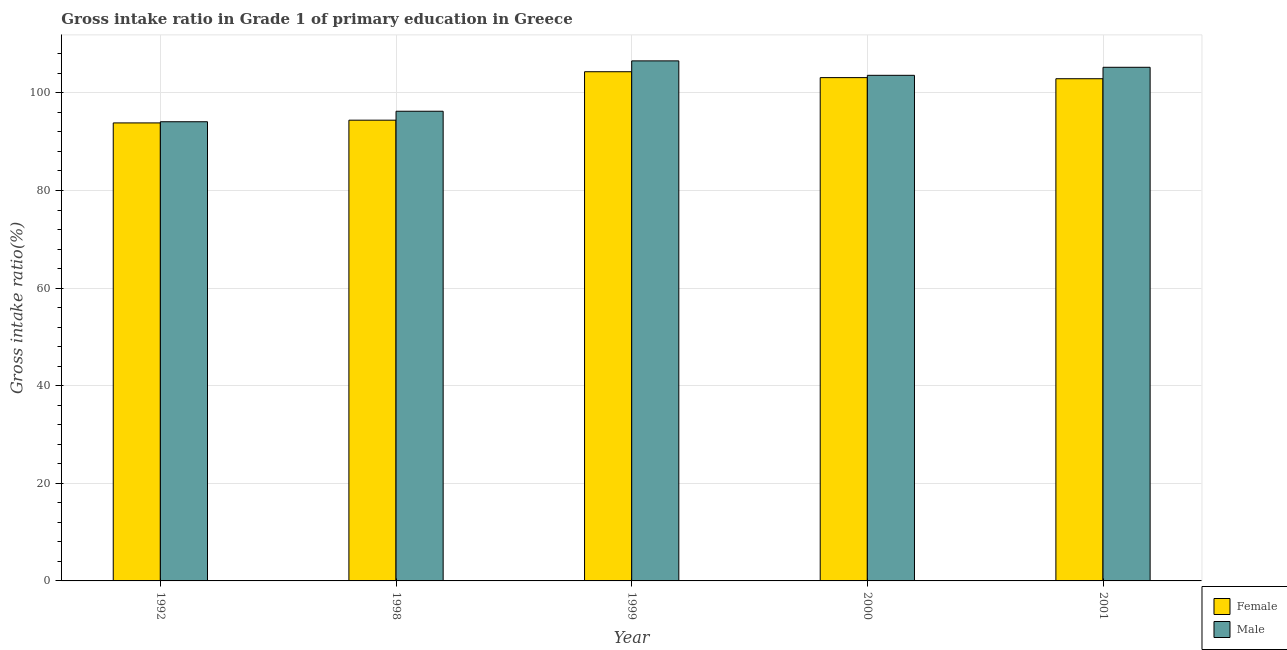How many groups of bars are there?
Provide a short and direct response. 5. Are the number of bars per tick equal to the number of legend labels?
Your response must be concise. Yes. Are the number of bars on each tick of the X-axis equal?
Offer a very short reply. Yes. How many bars are there on the 1st tick from the left?
Provide a succinct answer. 2. How many bars are there on the 1st tick from the right?
Offer a terse response. 2. What is the label of the 2nd group of bars from the left?
Offer a terse response. 1998. What is the gross intake ratio(female) in 1992?
Provide a short and direct response. 93.85. Across all years, what is the maximum gross intake ratio(female)?
Your answer should be very brief. 104.33. Across all years, what is the minimum gross intake ratio(male)?
Your answer should be compact. 94.09. In which year was the gross intake ratio(female) minimum?
Ensure brevity in your answer.  1992. What is the total gross intake ratio(female) in the graph?
Give a very brief answer. 498.61. What is the difference between the gross intake ratio(male) in 1992 and that in 2000?
Offer a very short reply. -9.51. What is the difference between the gross intake ratio(female) in 2001 and the gross intake ratio(male) in 1998?
Offer a terse response. 8.49. What is the average gross intake ratio(female) per year?
Make the answer very short. 99.72. In the year 2000, what is the difference between the gross intake ratio(female) and gross intake ratio(male)?
Your response must be concise. 0. In how many years, is the gross intake ratio(male) greater than 16 %?
Keep it short and to the point. 5. What is the ratio of the gross intake ratio(male) in 1992 to that in 2000?
Offer a terse response. 0.91. Is the gross intake ratio(female) in 1992 less than that in 2001?
Offer a terse response. Yes. Is the difference between the gross intake ratio(male) in 1992 and 2000 greater than the difference between the gross intake ratio(female) in 1992 and 2000?
Provide a succinct answer. No. What is the difference between the highest and the second highest gross intake ratio(male)?
Your answer should be very brief. 1.31. What is the difference between the highest and the lowest gross intake ratio(male)?
Provide a short and direct response. 12.47. In how many years, is the gross intake ratio(female) greater than the average gross intake ratio(female) taken over all years?
Provide a succinct answer. 3. Are all the bars in the graph horizontal?
Provide a succinct answer. No. How many years are there in the graph?
Offer a terse response. 5. Are the values on the major ticks of Y-axis written in scientific E-notation?
Offer a terse response. No. Does the graph contain any zero values?
Offer a very short reply. No. Does the graph contain grids?
Provide a succinct answer. Yes. Where does the legend appear in the graph?
Provide a succinct answer. Bottom right. How many legend labels are there?
Your response must be concise. 2. How are the legend labels stacked?
Give a very brief answer. Vertical. What is the title of the graph?
Provide a succinct answer. Gross intake ratio in Grade 1 of primary education in Greece. Does "Private consumption" appear as one of the legend labels in the graph?
Offer a very short reply. No. What is the label or title of the X-axis?
Ensure brevity in your answer.  Year. What is the label or title of the Y-axis?
Offer a very short reply. Gross intake ratio(%). What is the Gross intake ratio(%) in Female in 1992?
Your answer should be compact. 93.85. What is the Gross intake ratio(%) in Male in 1992?
Provide a short and direct response. 94.09. What is the Gross intake ratio(%) in Female in 1998?
Provide a short and direct response. 94.41. What is the Gross intake ratio(%) in Male in 1998?
Your answer should be compact. 96.24. What is the Gross intake ratio(%) of Female in 1999?
Offer a terse response. 104.33. What is the Gross intake ratio(%) in Male in 1999?
Offer a very short reply. 106.56. What is the Gross intake ratio(%) of Female in 2000?
Offer a very short reply. 103.13. What is the Gross intake ratio(%) in Male in 2000?
Offer a terse response. 103.6. What is the Gross intake ratio(%) of Female in 2001?
Your response must be concise. 102.9. What is the Gross intake ratio(%) of Male in 2001?
Provide a succinct answer. 105.25. Across all years, what is the maximum Gross intake ratio(%) in Female?
Your answer should be very brief. 104.33. Across all years, what is the maximum Gross intake ratio(%) in Male?
Offer a very short reply. 106.56. Across all years, what is the minimum Gross intake ratio(%) of Female?
Make the answer very short. 93.85. Across all years, what is the minimum Gross intake ratio(%) of Male?
Provide a short and direct response. 94.09. What is the total Gross intake ratio(%) of Female in the graph?
Give a very brief answer. 498.61. What is the total Gross intake ratio(%) in Male in the graph?
Your response must be concise. 505.72. What is the difference between the Gross intake ratio(%) of Female in 1992 and that in 1998?
Provide a succinct answer. -0.56. What is the difference between the Gross intake ratio(%) in Male in 1992 and that in 1998?
Give a very brief answer. -2.15. What is the difference between the Gross intake ratio(%) of Female in 1992 and that in 1999?
Ensure brevity in your answer.  -10.49. What is the difference between the Gross intake ratio(%) of Male in 1992 and that in 1999?
Provide a succinct answer. -12.47. What is the difference between the Gross intake ratio(%) in Female in 1992 and that in 2000?
Provide a short and direct response. -9.28. What is the difference between the Gross intake ratio(%) of Male in 1992 and that in 2000?
Provide a succinct answer. -9.51. What is the difference between the Gross intake ratio(%) in Female in 1992 and that in 2001?
Provide a short and direct response. -9.05. What is the difference between the Gross intake ratio(%) in Male in 1992 and that in 2001?
Your answer should be very brief. -11.16. What is the difference between the Gross intake ratio(%) of Female in 1998 and that in 1999?
Keep it short and to the point. -9.93. What is the difference between the Gross intake ratio(%) in Male in 1998 and that in 1999?
Your answer should be very brief. -10.32. What is the difference between the Gross intake ratio(%) of Female in 1998 and that in 2000?
Make the answer very short. -8.72. What is the difference between the Gross intake ratio(%) of Male in 1998 and that in 2000?
Offer a terse response. -7.36. What is the difference between the Gross intake ratio(%) of Female in 1998 and that in 2001?
Keep it short and to the point. -8.49. What is the difference between the Gross intake ratio(%) in Male in 1998 and that in 2001?
Ensure brevity in your answer.  -9.01. What is the difference between the Gross intake ratio(%) of Female in 1999 and that in 2000?
Keep it short and to the point. 1.21. What is the difference between the Gross intake ratio(%) of Male in 1999 and that in 2000?
Make the answer very short. 2.96. What is the difference between the Gross intake ratio(%) of Female in 1999 and that in 2001?
Provide a succinct answer. 1.44. What is the difference between the Gross intake ratio(%) of Male in 1999 and that in 2001?
Ensure brevity in your answer.  1.31. What is the difference between the Gross intake ratio(%) of Female in 2000 and that in 2001?
Offer a very short reply. 0.23. What is the difference between the Gross intake ratio(%) in Male in 2000 and that in 2001?
Your answer should be compact. -1.65. What is the difference between the Gross intake ratio(%) in Female in 1992 and the Gross intake ratio(%) in Male in 1998?
Provide a succinct answer. -2.39. What is the difference between the Gross intake ratio(%) in Female in 1992 and the Gross intake ratio(%) in Male in 1999?
Provide a succinct answer. -12.71. What is the difference between the Gross intake ratio(%) of Female in 1992 and the Gross intake ratio(%) of Male in 2000?
Your answer should be very brief. -9.75. What is the difference between the Gross intake ratio(%) in Female in 1992 and the Gross intake ratio(%) in Male in 2001?
Ensure brevity in your answer.  -11.4. What is the difference between the Gross intake ratio(%) in Female in 1998 and the Gross intake ratio(%) in Male in 1999?
Your response must be concise. -12.15. What is the difference between the Gross intake ratio(%) of Female in 1998 and the Gross intake ratio(%) of Male in 2000?
Your answer should be compact. -9.19. What is the difference between the Gross intake ratio(%) in Female in 1998 and the Gross intake ratio(%) in Male in 2001?
Keep it short and to the point. -10.84. What is the difference between the Gross intake ratio(%) of Female in 1999 and the Gross intake ratio(%) of Male in 2000?
Provide a short and direct response. 0.73. What is the difference between the Gross intake ratio(%) in Female in 1999 and the Gross intake ratio(%) in Male in 2001?
Ensure brevity in your answer.  -0.91. What is the difference between the Gross intake ratio(%) of Female in 2000 and the Gross intake ratio(%) of Male in 2001?
Offer a terse response. -2.12. What is the average Gross intake ratio(%) in Female per year?
Offer a very short reply. 99.72. What is the average Gross intake ratio(%) in Male per year?
Your answer should be very brief. 101.14. In the year 1992, what is the difference between the Gross intake ratio(%) in Female and Gross intake ratio(%) in Male?
Make the answer very short. -0.24. In the year 1998, what is the difference between the Gross intake ratio(%) in Female and Gross intake ratio(%) in Male?
Give a very brief answer. -1.83. In the year 1999, what is the difference between the Gross intake ratio(%) of Female and Gross intake ratio(%) of Male?
Your response must be concise. -2.22. In the year 2000, what is the difference between the Gross intake ratio(%) of Female and Gross intake ratio(%) of Male?
Keep it short and to the point. -0.47. In the year 2001, what is the difference between the Gross intake ratio(%) in Female and Gross intake ratio(%) in Male?
Your answer should be compact. -2.35. What is the ratio of the Gross intake ratio(%) of Male in 1992 to that in 1998?
Ensure brevity in your answer.  0.98. What is the ratio of the Gross intake ratio(%) of Female in 1992 to that in 1999?
Offer a terse response. 0.9. What is the ratio of the Gross intake ratio(%) in Male in 1992 to that in 1999?
Give a very brief answer. 0.88. What is the ratio of the Gross intake ratio(%) in Female in 1992 to that in 2000?
Provide a short and direct response. 0.91. What is the ratio of the Gross intake ratio(%) in Male in 1992 to that in 2000?
Your answer should be very brief. 0.91. What is the ratio of the Gross intake ratio(%) in Female in 1992 to that in 2001?
Offer a very short reply. 0.91. What is the ratio of the Gross intake ratio(%) of Male in 1992 to that in 2001?
Your answer should be compact. 0.89. What is the ratio of the Gross intake ratio(%) of Female in 1998 to that in 1999?
Your answer should be compact. 0.9. What is the ratio of the Gross intake ratio(%) in Male in 1998 to that in 1999?
Your answer should be compact. 0.9. What is the ratio of the Gross intake ratio(%) in Female in 1998 to that in 2000?
Offer a very short reply. 0.92. What is the ratio of the Gross intake ratio(%) of Male in 1998 to that in 2000?
Give a very brief answer. 0.93. What is the ratio of the Gross intake ratio(%) in Female in 1998 to that in 2001?
Keep it short and to the point. 0.92. What is the ratio of the Gross intake ratio(%) of Male in 1998 to that in 2001?
Your answer should be very brief. 0.91. What is the ratio of the Gross intake ratio(%) in Female in 1999 to that in 2000?
Your answer should be very brief. 1.01. What is the ratio of the Gross intake ratio(%) in Male in 1999 to that in 2000?
Your answer should be compact. 1.03. What is the ratio of the Gross intake ratio(%) of Female in 1999 to that in 2001?
Provide a short and direct response. 1.01. What is the ratio of the Gross intake ratio(%) of Male in 1999 to that in 2001?
Keep it short and to the point. 1.01. What is the ratio of the Gross intake ratio(%) in Female in 2000 to that in 2001?
Provide a succinct answer. 1. What is the ratio of the Gross intake ratio(%) in Male in 2000 to that in 2001?
Keep it short and to the point. 0.98. What is the difference between the highest and the second highest Gross intake ratio(%) of Female?
Keep it short and to the point. 1.21. What is the difference between the highest and the second highest Gross intake ratio(%) of Male?
Ensure brevity in your answer.  1.31. What is the difference between the highest and the lowest Gross intake ratio(%) in Female?
Keep it short and to the point. 10.49. What is the difference between the highest and the lowest Gross intake ratio(%) of Male?
Offer a terse response. 12.47. 